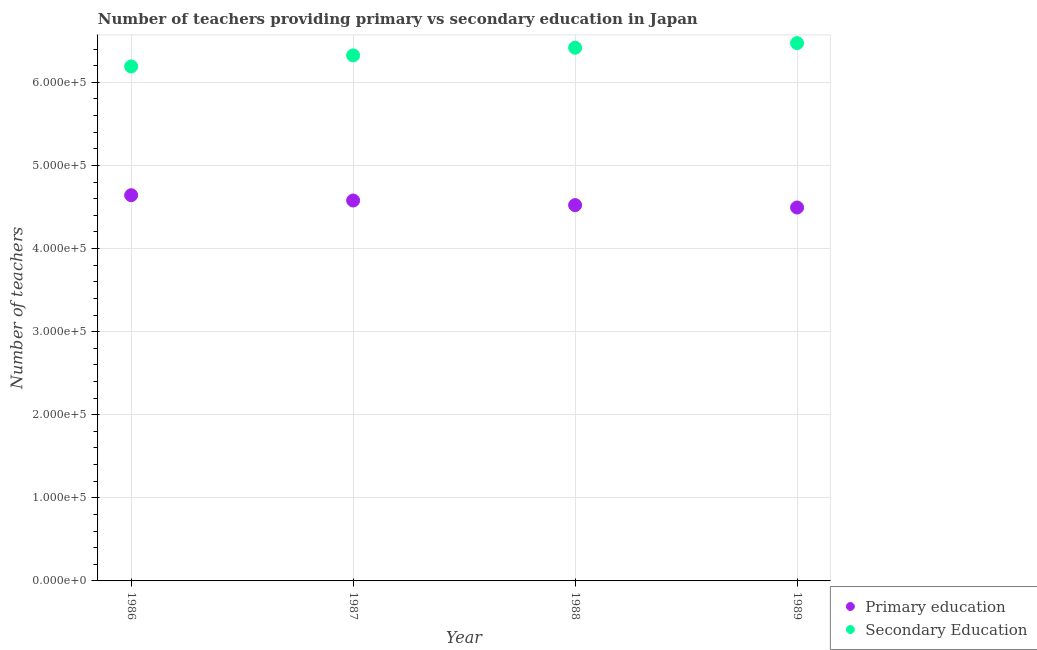How many different coloured dotlines are there?
Keep it short and to the point. 2. Is the number of dotlines equal to the number of legend labels?
Your answer should be very brief. Yes. What is the number of secondary teachers in 1989?
Your answer should be very brief. 6.47e+05. Across all years, what is the maximum number of secondary teachers?
Keep it short and to the point. 6.47e+05. Across all years, what is the minimum number of secondary teachers?
Offer a very short reply. 6.19e+05. In which year was the number of primary teachers minimum?
Keep it short and to the point. 1989. What is the total number of primary teachers in the graph?
Your answer should be very brief. 1.82e+06. What is the difference between the number of secondary teachers in 1986 and that in 1989?
Your answer should be compact. -2.81e+04. What is the difference between the number of secondary teachers in 1987 and the number of primary teachers in 1986?
Offer a terse response. 1.68e+05. What is the average number of secondary teachers per year?
Your answer should be compact. 6.35e+05. In the year 1986, what is the difference between the number of primary teachers and number of secondary teachers?
Your answer should be very brief. -1.55e+05. In how many years, is the number of primary teachers greater than 500000?
Your answer should be very brief. 0. What is the ratio of the number of secondary teachers in 1986 to that in 1989?
Offer a very short reply. 0.96. Is the number of primary teachers in 1987 less than that in 1988?
Keep it short and to the point. No. What is the difference between the highest and the second highest number of primary teachers?
Your response must be concise. 6406. What is the difference between the highest and the lowest number of primary teachers?
Offer a very short reply. 1.48e+04. Is the sum of the number of primary teachers in 1987 and 1989 greater than the maximum number of secondary teachers across all years?
Keep it short and to the point. Yes. Is the number of primary teachers strictly greater than the number of secondary teachers over the years?
Your response must be concise. No. Is the number of secondary teachers strictly less than the number of primary teachers over the years?
Your answer should be compact. No. Are the values on the major ticks of Y-axis written in scientific E-notation?
Offer a terse response. Yes. Does the graph contain grids?
Give a very brief answer. Yes. What is the title of the graph?
Offer a terse response. Number of teachers providing primary vs secondary education in Japan. What is the label or title of the X-axis?
Offer a very short reply. Year. What is the label or title of the Y-axis?
Your response must be concise. Number of teachers. What is the Number of teachers of Primary education in 1986?
Give a very brief answer. 4.64e+05. What is the Number of teachers of Secondary Education in 1986?
Your response must be concise. 6.19e+05. What is the Number of teachers of Primary education in 1987?
Your answer should be very brief. 4.58e+05. What is the Number of teachers of Secondary Education in 1987?
Provide a succinct answer. 6.32e+05. What is the Number of teachers of Primary education in 1988?
Give a very brief answer. 4.52e+05. What is the Number of teachers in Secondary Education in 1988?
Provide a succinct answer. 6.42e+05. What is the Number of teachers of Primary education in 1989?
Your response must be concise. 4.49e+05. What is the Number of teachers in Secondary Education in 1989?
Your answer should be compact. 6.47e+05. Across all years, what is the maximum Number of teachers of Primary education?
Offer a terse response. 4.64e+05. Across all years, what is the maximum Number of teachers in Secondary Education?
Provide a succinct answer. 6.47e+05. Across all years, what is the minimum Number of teachers in Primary education?
Keep it short and to the point. 4.49e+05. Across all years, what is the minimum Number of teachers in Secondary Education?
Provide a short and direct response. 6.19e+05. What is the total Number of teachers of Primary education in the graph?
Make the answer very short. 1.82e+06. What is the total Number of teachers in Secondary Education in the graph?
Make the answer very short. 2.54e+06. What is the difference between the Number of teachers of Primary education in 1986 and that in 1987?
Offer a terse response. 6406. What is the difference between the Number of teachers in Secondary Education in 1986 and that in 1987?
Your answer should be very brief. -1.33e+04. What is the difference between the Number of teachers in Primary education in 1986 and that in 1988?
Offer a very short reply. 1.20e+04. What is the difference between the Number of teachers of Secondary Education in 1986 and that in 1988?
Provide a succinct answer. -2.25e+04. What is the difference between the Number of teachers in Primary education in 1986 and that in 1989?
Provide a short and direct response. 1.48e+04. What is the difference between the Number of teachers in Secondary Education in 1986 and that in 1989?
Provide a short and direct response. -2.81e+04. What is the difference between the Number of teachers in Primary education in 1987 and that in 1988?
Keep it short and to the point. 5547. What is the difference between the Number of teachers in Secondary Education in 1987 and that in 1988?
Provide a short and direct response. -9190. What is the difference between the Number of teachers in Primary education in 1987 and that in 1989?
Provide a short and direct response. 8420. What is the difference between the Number of teachers in Secondary Education in 1987 and that in 1989?
Give a very brief answer. -1.48e+04. What is the difference between the Number of teachers of Primary education in 1988 and that in 1989?
Offer a very short reply. 2873. What is the difference between the Number of teachers of Secondary Education in 1988 and that in 1989?
Provide a short and direct response. -5578. What is the difference between the Number of teachers in Primary education in 1986 and the Number of teachers in Secondary Education in 1987?
Keep it short and to the point. -1.68e+05. What is the difference between the Number of teachers in Primary education in 1986 and the Number of teachers in Secondary Education in 1988?
Keep it short and to the point. -1.77e+05. What is the difference between the Number of teachers in Primary education in 1986 and the Number of teachers in Secondary Education in 1989?
Offer a very short reply. -1.83e+05. What is the difference between the Number of teachers in Primary education in 1987 and the Number of teachers in Secondary Education in 1988?
Offer a terse response. -1.84e+05. What is the difference between the Number of teachers in Primary education in 1987 and the Number of teachers in Secondary Education in 1989?
Your answer should be very brief. -1.89e+05. What is the difference between the Number of teachers in Primary education in 1988 and the Number of teachers in Secondary Education in 1989?
Your response must be concise. -1.95e+05. What is the average Number of teachers of Primary education per year?
Provide a succinct answer. 4.56e+05. What is the average Number of teachers in Secondary Education per year?
Provide a short and direct response. 6.35e+05. In the year 1986, what is the difference between the Number of teachers of Primary education and Number of teachers of Secondary Education?
Offer a very short reply. -1.55e+05. In the year 1987, what is the difference between the Number of teachers in Primary education and Number of teachers in Secondary Education?
Provide a succinct answer. -1.75e+05. In the year 1988, what is the difference between the Number of teachers of Primary education and Number of teachers of Secondary Education?
Give a very brief answer. -1.89e+05. In the year 1989, what is the difference between the Number of teachers in Primary education and Number of teachers in Secondary Education?
Keep it short and to the point. -1.98e+05. What is the ratio of the Number of teachers of Secondary Education in 1986 to that in 1987?
Provide a succinct answer. 0.98. What is the ratio of the Number of teachers of Primary education in 1986 to that in 1988?
Offer a terse response. 1.03. What is the ratio of the Number of teachers in Secondary Education in 1986 to that in 1988?
Your response must be concise. 0.96. What is the ratio of the Number of teachers in Primary education in 1986 to that in 1989?
Provide a succinct answer. 1.03. What is the ratio of the Number of teachers in Secondary Education in 1986 to that in 1989?
Offer a very short reply. 0.96. What is the ratio of the Number of teachers of Primary education in 1987 to that in 1988?
Your answer should be compact. 1.01. What is the ratio of the Number of teachers of Secondary Education in 1987 to that in 1988?
Your response must be concise. 0.99. What is the ratio of the Number of teachers of Primary education in 1987 to that in 1989?
Ensure brevity in your answer.  1.02. What is the ratio of the Number of teachers of Secondary Education in 1987 to that in 1989?
Your answer should be very brief. 0.98. What is the ratio of the Number of teachers in Primary education in 1988 to that in 1989?
Ensure brevity in your answer.  1.01. What is the ratio of the Number of teachers in Secondary Education in 1988 to that in 1989?
Make the answer very short. 0.99. What is the difference between the highest and the second highest Number of teachers of Primary education?
Offer a terse response. 6406. What is the difference between the highest and the second highest Number of teachers in Secondary Education?
Provide a succinct answer. 5578. What is the difference between the highest and the lowest Number of teachers in Primary education?
Provide a succinct answer. 1.48e+04. What is the difference between the highest and the lowest Number of teachers in Secondary Education?
Ensure brevity in your answer.  2.81e+04. 